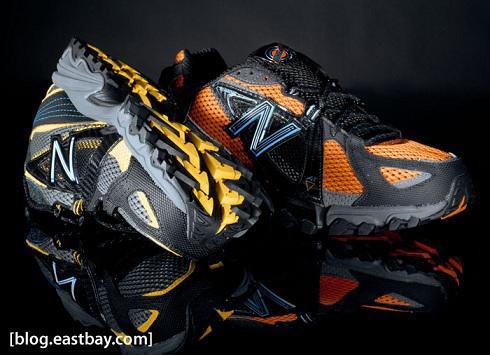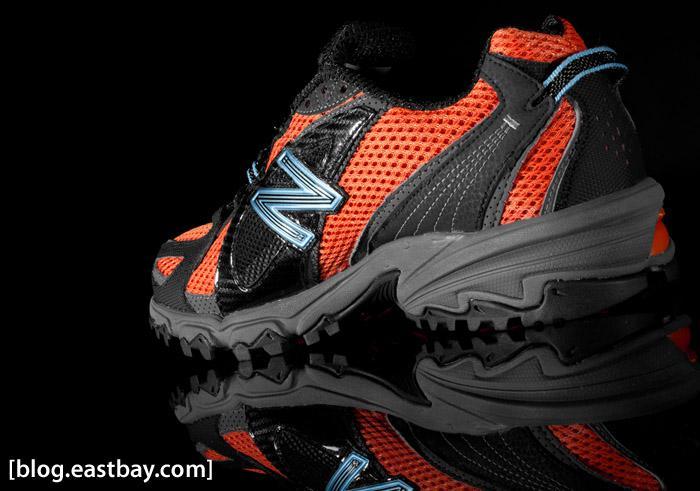The first image is the image on the left, the second image is the image on the right. For the images displayed, is the sentence "There are fewer than four shoes in total." factually correct? Answer yes or no. Yes. The first image is the image on the left, the second image is the image on the right. For the images shown, is this caption "There are more shoes in the image on the right." true? Answer yes or no. No. 